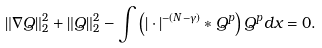Convert formula to latex. <formula><loc_0><loc_0><loc_500><loc_500>\| \nabla Q \| _ { 2 } ^ { 2 } + \| Q \| _ { 2 } ^ { 2 } - \int \left ( | \cdot | ^ { - ( N - \gamma ) } * Q ^ { p } \right ) Q ^ { p } d x = 0 .</formula> 